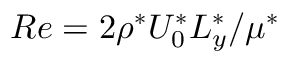Convert formula to latex. <formula><loc_0><loc_0><loc_500><loc_500>R e = 2 \rho ^ { * } U _ { 0 } ^ { * } L _ { y } ^ { * } / \mu ^ { * }</formula> 